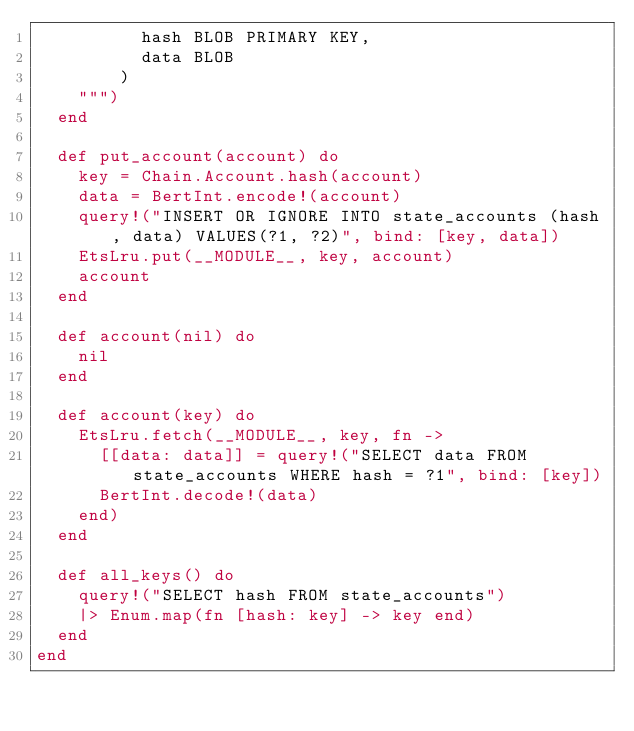<code> <loc_0><loc_0><loc_500><loc_500><_Elixir_>          hash BLOB PRIMARY KEY,
          data BLOB
        )
    """)
  end

  def put_account(account) do
    key = Chain.Account.hash(account)
    data = BertInt.encode!(account)
    query!("INSERT OR IGNORE INTO state_accounts (hash, data) VALUES(?1, ?2)", bind: [key, data])
    EtsLru.put(__MODULE__, key, account)
    account
  end

  def account(nil) do
    nil
  end

  def account(key) do
    EtsLru.fetch(__MODULE__, key, fn ->
      [[data: data]] = query!("SELECT data FROM state_accounts WHERE hash = ?1", bind: [key])
      BertInt.decode!(data)
    end)
  end

  def all_keys() do
    query!("SELECT hash FROM state_accounts")
    |> Enum.map(fn [hash: key] -> key end)
  end
end
</code> 